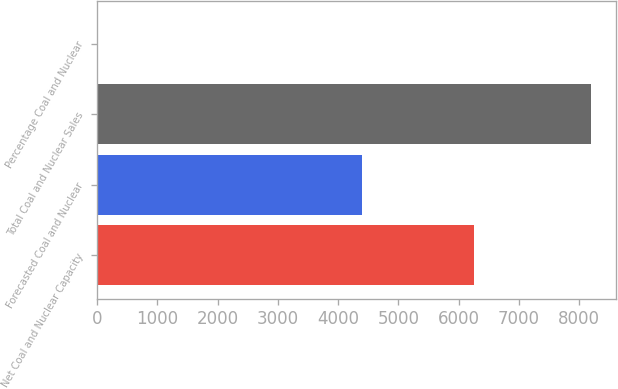Convert chart. <chart><loc_0><loc_0><loc_500><loc_500><bar_chart><fcel>Net Coal and Nuclear Capacity<fcel>Forecasted Coal and Nuclear<fcel>Total Coal and Nuclear Sales<fcel>Percentage Coal and Nuclear<nl><fcel>6250<fcel>4402<fcel>8203<fcel>21<nl></chart> 